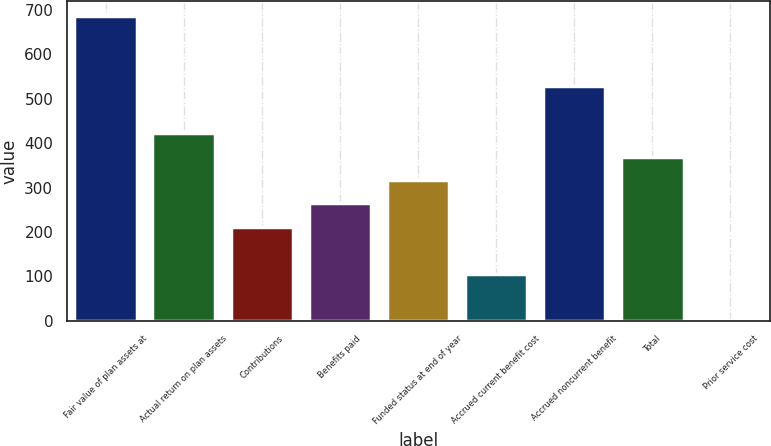Convert chart to OTSL. <chart><loc_0><loc_0><loc_500><loc_500><bar_chart><fcel>Fair value of plan assets at<fcel>Actual return on plan assets<fcel>Contributions<fcel>Benefits paid<fcel>Funded status at end of year<fcel>Accrued current benefit cost<fcel>Accrued noncurrent benefit<fcel>Total<fcel>Prior service cost<nl><fcel>686.23<fcel>422.68<fcel>211.84<fcel>264.55<fcel>317.26<fcel>106.42<fcel>528.1<fcel>369.97<fcel>1<nl></chart> 